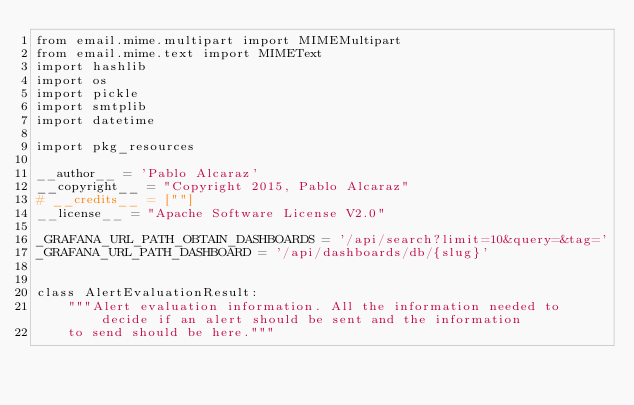<code> <loc_0><loc_0><loc_500><loc_500><_Python_>from email.mime.multipart import MIMEMultipart
from email.mime.text import MIMEText
import hashlib
import os
import pickle
import smtplib
import datetime

import pkg_resources

__author__ = 'Pablo Alcaraz'
__copyright__ = "Copyright 2015, Pablo Alcaraz"
# __credits__ = [""]
__license__ = "Apache Software License V2.0"

_GRAFANA_URL_PATH_OBTAIN_DASHBOARDS = '/api/search?limit=10&query=&tag='
_GRAFANA_URL_PATH_DASHBOARD = '/api/dashboards/db/{slug}'


class AlertEvaluationResult:
    """Alert evaluation information. All the information needed to decide if an alert should be sent and the information
    to send should be here."""
</code> 